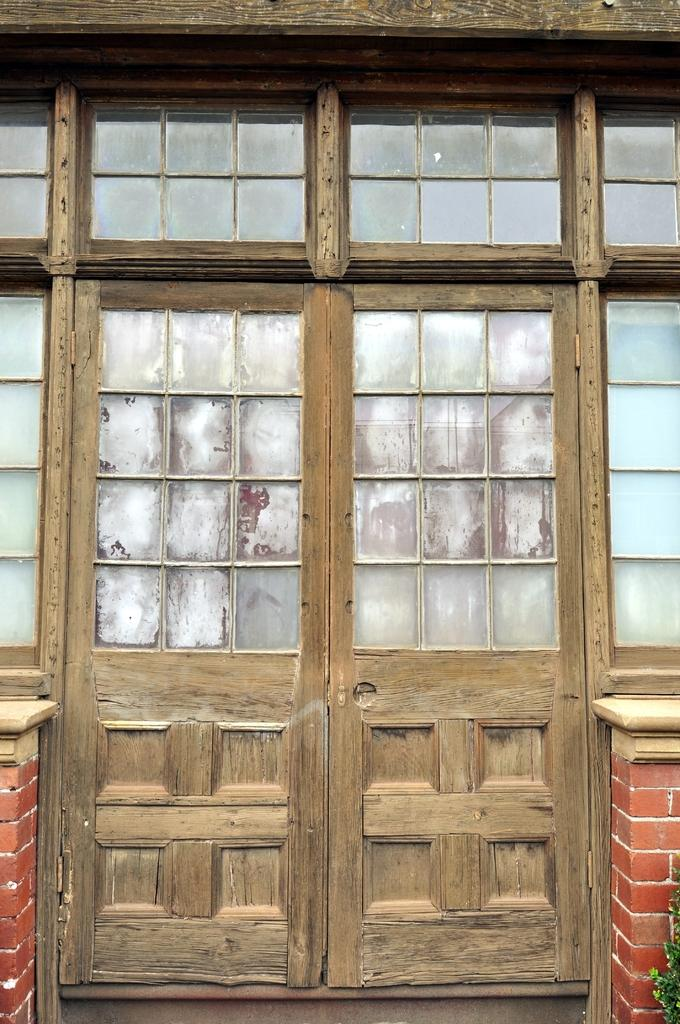What type of door is visible in the image? There is a wooden door in the image. Is there anything near the door in the image? Yes, there is a plant on the right side of the door. What type of coil is present in the image? There is no coil present in the image. What religion is depicted in the image? The image does not depict any religious symbols or themes. 